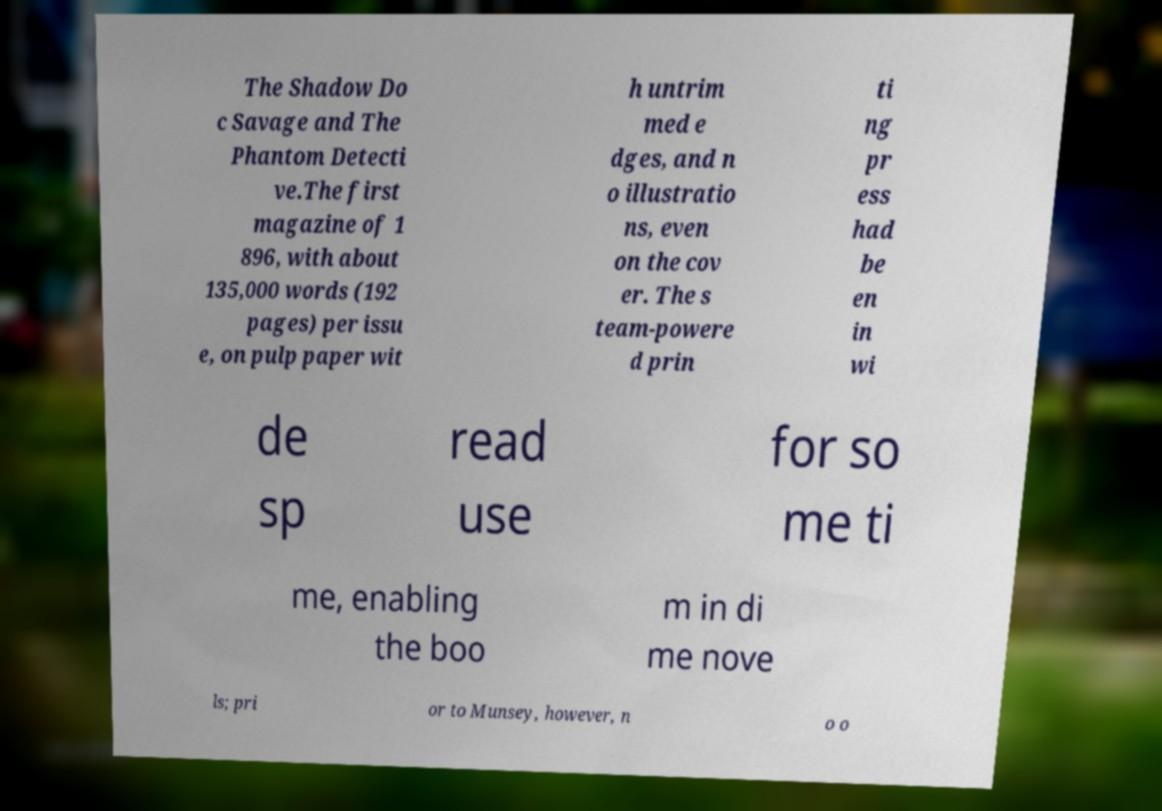Please read and relay the text visible in this image. What does it say? The Shadow Do c Savage and The Phantom Detecti ve.The first magazine of 1 896, with about 135,000 words (192 pages) per issu e, on pulp paper wit h untrim med e dges, and n o illustratio ns, even on the cov er. The s team-powere d prin ti ng pr ess had be en in wi de sp read use for so me ti me, enabling the boo m in di me nove ls; pri or to Munsey, however, n o o 